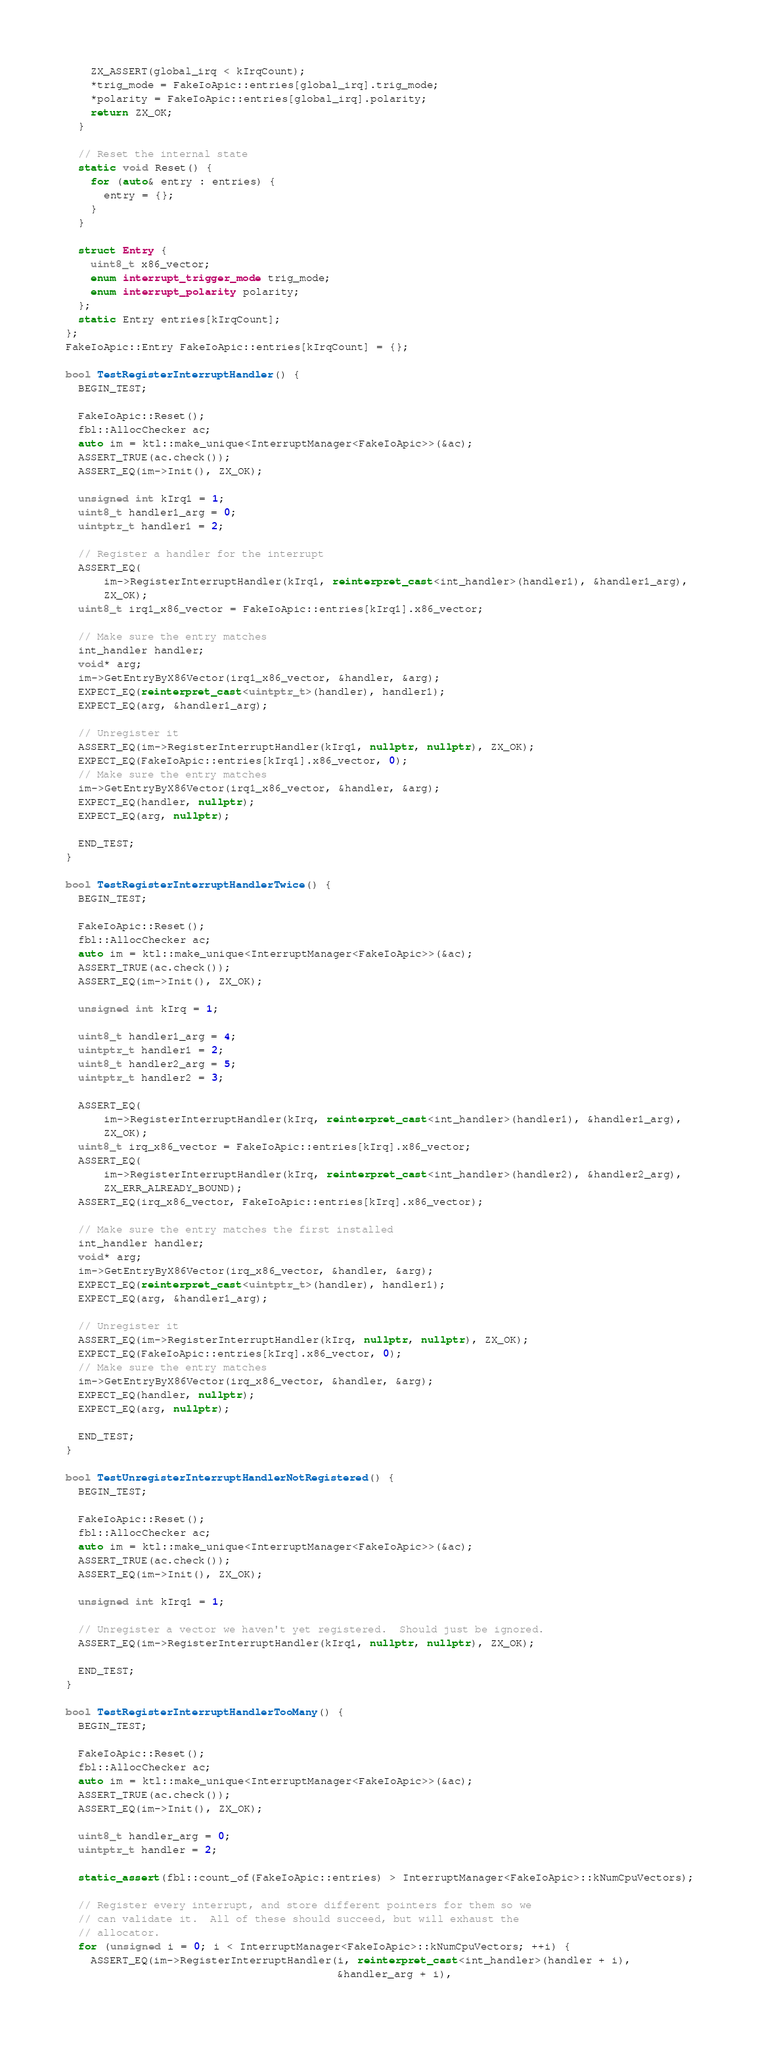<code> <loc_0><loc_0><loc_500><loc_500><_C++_>    ZX_ASSERT(global_irq < kIrqCount);
    *trig_mode = FakeIoApic::entries[global_irq].trig_mode;
    *polarity = FakeIoApic::entries[global_irq].polarity;
    return ZX_OK;
  }

  // Reset the internal state
  static void Reset() {
    for (auto& entry : entries) {
      entry = {};
    }
  }

  struct Entry {
    uint8_t x86_vector;
    enum interrupt_trigger_mode trig_mode;
    enum interrupt_polarity polarity;
  };
  static Entry entries[kIrqCount];
};
FakeIoApic::Entry FakeIoApic::entries[kIrqCount] = {};

bool TestRegisterInterruptHandler() {
  BEGIN_TEST;

  FakeIoApic::Reset();
  fbl::AllocChecker ac;
  auto im = ktl::make_unique<InterruptManager<FakeIoApic>>(&ac);
  ASSERT_TRUE(ac.check());
  ASSERT_EQ(im->Init(), ZX_OK);

  unsigned int kIrq1 = 1;
  uint8_t handler1_arg = 0;
  uintptr_t handler1 = 2;

  // Register a handler for the interrupt
  ASSERT_EQ(
      im->RegisterInterruptHandler(kIrq1, reinterpret_cast<int_handler>(handler1), &handler1_arg),
      ZX_OK);
  uint8_t irq1_x86_vector = FakeIoApic::entries[kIrq1].x86_vector;

  // Make sure the entry matches
  int_handler handler;
  void* arg;
  im->GetEntryByX86Vector(irq1_x86_vector, &handler, &arg);
  EXPECT_EQ(reinterpret_cast<uintptr_t>(handler), handler1);
  EXPECT_EQ(arg, &handler1_arg);

  // Unregister it
  ASSERT_EQ(im->RegisterInterruptHandler(kIrq1, nullptr, nullptr), ZX_OK);
  EXPECT_EQ(FakeIoApic::entries[kIrq1].x86_vector, 0);
  // Make sure the entry matches
  im->GetEntryByX86Vector(irq1_x86_vector, &handler, &arg);
  EXPECT_EQ(handler, nullptr);
  EXPECT_EQ(arg, nullptr);

  END_TEST;
}

bool TestRegisterInterruptHandlerTwice() {
  BEGIN_TEST;

  FakeIoApic::Reset();
  fbl::AllocChecker ac;
  auto im = ktl::make_unique<InterruptManager<FakeIoApic>>(&ac);
  ASSERT_TRUE(ac.check());
  ASSERT_EQ(im->Init(), ZX_OK);

  unsigned int kIrq = 1;

  uint8_t handler1_arg = 4;
  uintptr_t handler1 = 2;
  uint8_t handler2_arg = 5;
  uintptr_t handler2 = 3;

  ASSERT_EQ(
      im->RegisterInterruptHandler(kIrq, reinterpret_cast<int_handler>(handler1), &handler1_arg),
      ZX_OK);
  uint8_t irq_x86_vector = FakeIoApic::entries[kIrq].x86_vector;
  ASSERT_EQ(
      im->RegisterInterruptHandler(kIrq, reinterpret_cast<int_handler>(handler2), &handler2_arg),
      ZX_ERR_ALREADY_BOUND);
  ASSERT_EQ(irq_x86_vector, FakeIoApic::entries[kIrq].x86_vector);

  // Make sure the entry matches the first installed
  int_handler handler;
  void* arg;
  im->GetEntryByX86Vector(irq_x86_vector, &handler, &arg);
  EXPECT_EQ(reinterpret_cast<uintptr_t>(handler), handler1);
  EXPECT_EQ(arg, &handler1_arg);

  // Unregister it
  ASSERT_EQ(im->RegisterInterruptHandler(kIrq, nullptr, nullptr), ZX_OK);
  EXPECT_EQ(FakeIoApic::entries[kIrq].x86_vector, 0);
  // Make sure the entry matches
  im->GetEntryByX86Vector(irq_x86_vector, &handler, &arg);
  EXPECT_EQ(handler, nullptr);
  EXPECT_EQ(arg, nullptr);

  END_TEST;
}

bool TestUnregisterInterruptHandlerNotRegistered() {
  BEGIN_TEST;

  FakeIoApic::Reset();
  fbl::AllocChecker ac;
  auto im = ktl::make_unique<InterruptManager<FakeIoApic>>(&ac);
  ASSERT_TRUE(ac.check());
  ASSERT_EQ(im->Init(), ZX_OK);

  unsigned int kIrq1 = 1;

  // Unregister a vector we haven't yet registered.  Should just be ignored.
  ASSERT_EQ(im->RegisterInterruptHandler(kIrq1, nullptr, nullptr), ZX_OK);

  END_TEST;
}

bool TestRegisterInterruptHandlerTooMany() {
  BEGIN_TEST;

  FakeIoApic::Reset();
  fbl::AllocChecker ac;
  auto im = ktl::make_unique<InterruptManager<FakeIoApic>>(&ac);
  ASSERT_TRUE(ac.check());
  ASSERT_EQ(im->Init(), ZX_OK);

  uint8_t handler_arg = 0;
  uintptr_t handler = 2;

  static_assert(fbl::count_of(FakeIoApic::entries) > InterruptManager<FakeIoApic>::kNumCpuVectors);

  // Register every interrupt, and store different pointers for them so we
  // can validate it.  All of these should succeed, but will exhaust the
  // allocator.
  for (unsigned i = 0; i < InterruptManager<FakeIoApic>::kNumCpuVectors; ++i) {
    ASSERT_EQ(im->RegisterInterruptHandler(i, reinterpret_cast<int_handler>(handler + i),
                                           &handler_arg + i),</code> 